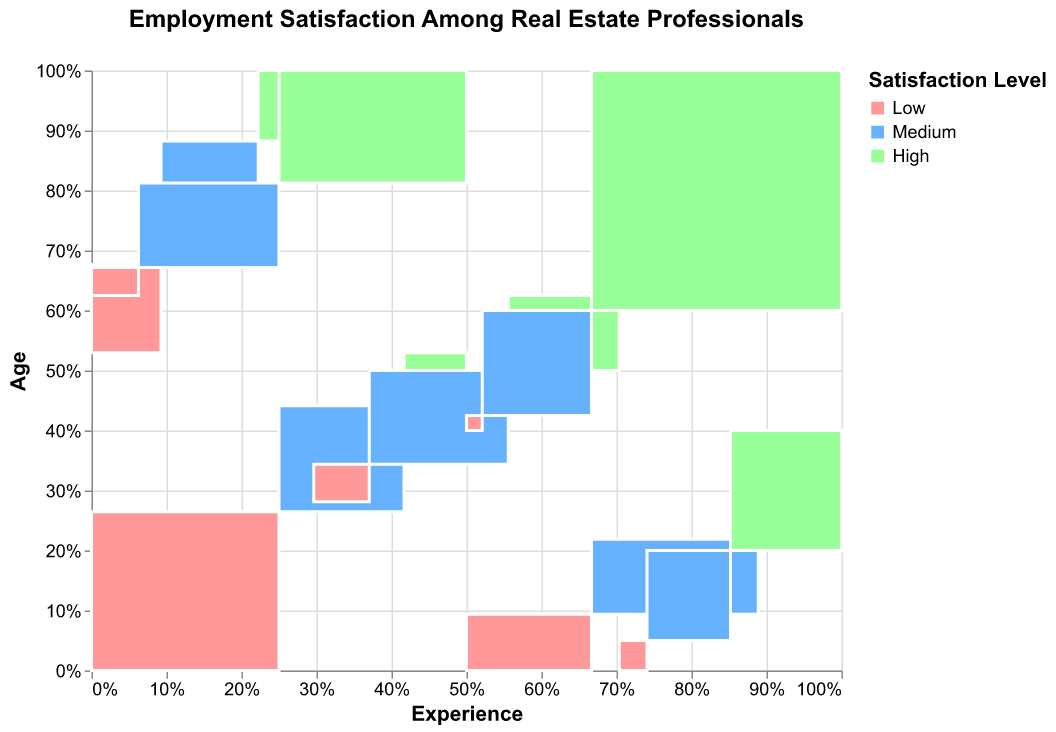What is the title of the figure? The title of the figure is displayed at the top and reads "Employment Satisfaction Among Real Estate Professionals".
Answer: Employment Satisfaction Among Real Estate Professionals How is the satisfaction distributed among the 20-30 age group with 0-2 years of experience? The distribution can be seen in the mosaic plot segment for the 20-30 age group with 0-2 years of experience. The proportion is divided into Low (45), Medium (30), and High (15) counts.
Answer: Low: 45, Medium: 30, High: 15 Which age group with 6+ years of experience has the highest satisfaction level? For age groups with 6+ years of experience, compare their satisfaction levels. The 41+ age group has 80 in High satisfaction, which is the highest.
Answer: 41+ age group How does the satisfaction level for the 31-40 age group with 3-5 years of experience compare to the 41+ age group with the same experience? Compare the segments for Low, Medium, and High satisfaction levels between these groups. The 31-40 group has counts of 20, 50, and 40, while the 41+ group has counts of 10, 30, and 40.
Answer: Both have Medium: 50 vs 30, High: 40 vs 40, Low: 20 vs 10 What is the most common satisfaction level for real estate professionals aged 31-40 with 6+ years of experience? By observing the colored segments for this group, the count for High satisfaction (60) is higher than Medium (45) and Low (15).
Answer: High satisfaction In the 31-40 age group, how does satisfaction change with increasing years of experience? Review the satisfaction levels across 0-2 years, 3-5 years, and 6+ years for the 31-40 group. There is a trend of increasing counts from Low to High satisfaction with more years of experience.
Answer: Increases with experience Which satisfaction level is least represented among the 41+ age group with 6+ years of experience? Check the counts for each satisfaction level in this age and experience group. The count for Low satisfaction is the least with a value of 5.
Answer: Low satisfaction How does the satisfaction distribution for 20-30 year-olds with 3-5 years of experience compare to 20-30 year-olds with 0-2 years of experience? Compare the counts for Low, Medium, and High satisfaction between these two experience groups in the 20-30 age range. Low (25 vs 45), Medium (35 vs 30), High (20 vs 15).
Answer: 3-5 years: More Medium and High, less Low Is there any age group that shows a clear increase in satisfaction with more experience? Examine age groups across different experience levels to observe any trends. The 31-40 age group shows an increase in Medium and High satisfaction levels with more experience.
Answer: 31-40 age group Does any age group have more Low satisfaction than High satisfaction? Compare the counts for Low and High satisfaction for each age group. The 20-30 age group has more Low (45) than High (15) satisfaction for 0-2 years of experience.
Answer: 20-30 age group with 0-2 years of experience 